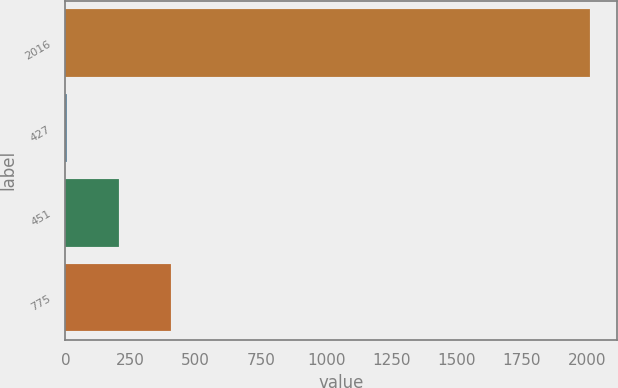Convert chart to OTSL. <chart><loc_0><loc_0><loc_500><loc_500><bar_chart><fcel>2016<fcel>427<fcel>451<fcel>775<nl><fcel>2014<fcel>4.08<fcel>205.07<fcel>406.06<nl></chart> 